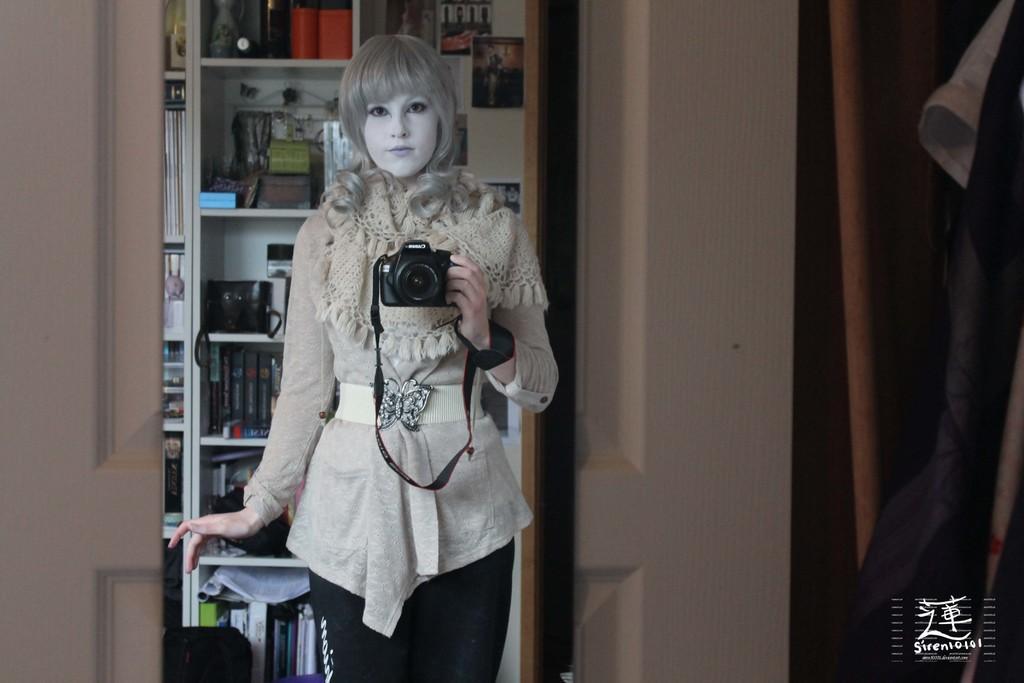Please provide a concise description of this image. In this image we can see a woman wearing a dress and holding a camera with her hand. In the background, we can see group of books and objects placed in racks, a door. To the right side, we can see some clothes. At the bottom we can see a logo and some text. 